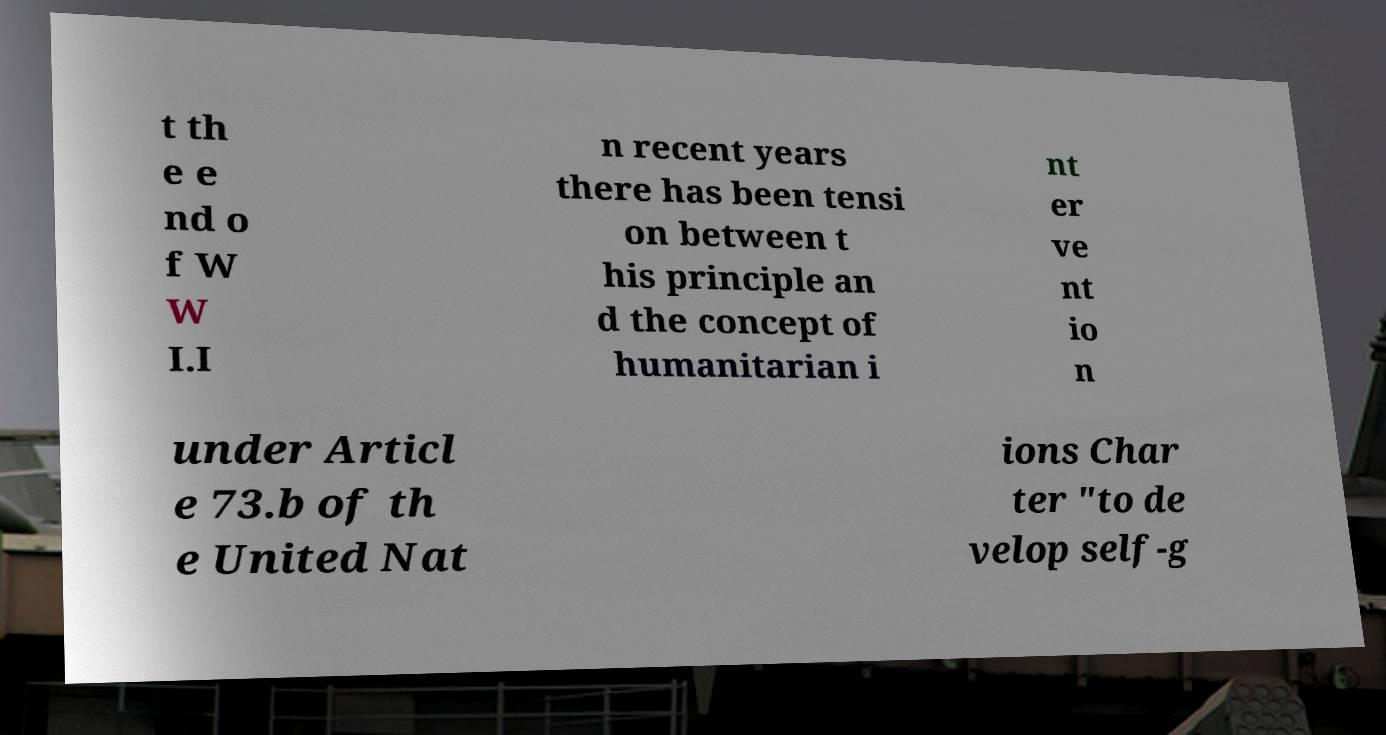Can you read and provide the text displayed in the image?This photo seems to have some interesting text. Can you extract and type it out for me? t th e e nd o f W W I.I n recent years there has been tensi on between t his principle an d the concept of humanitarian i nt er ve nt io n under Articl e 73.b of th e United Nat ions Char ter "to de velop self-g 